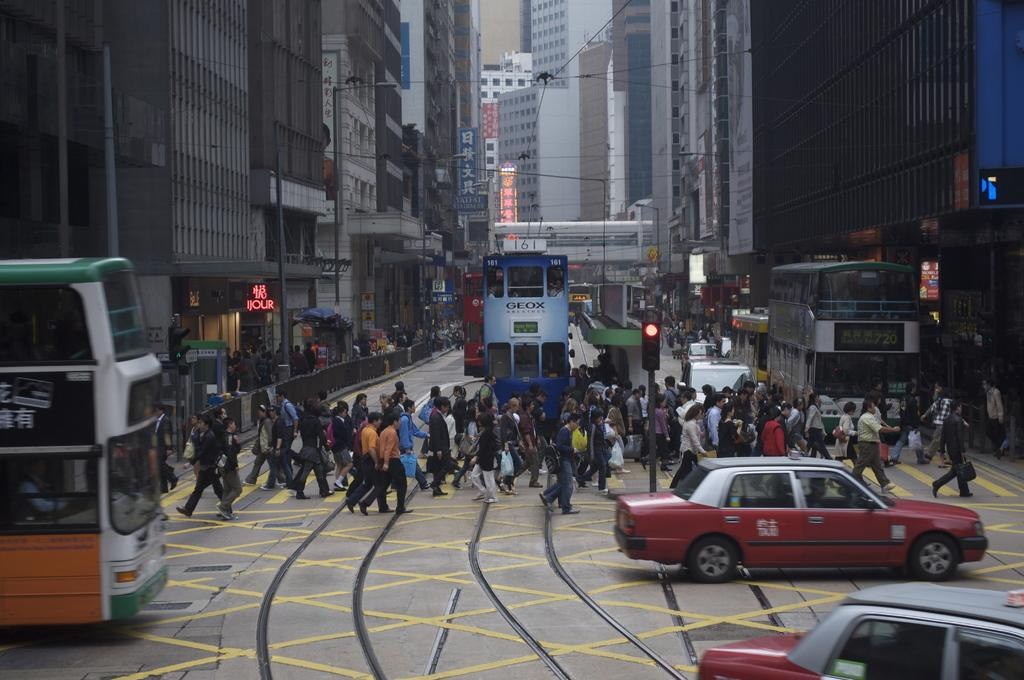<image>
Write a terse but informative summary of the picture. Streetcar 161 is on the street along with many pedestrians. 